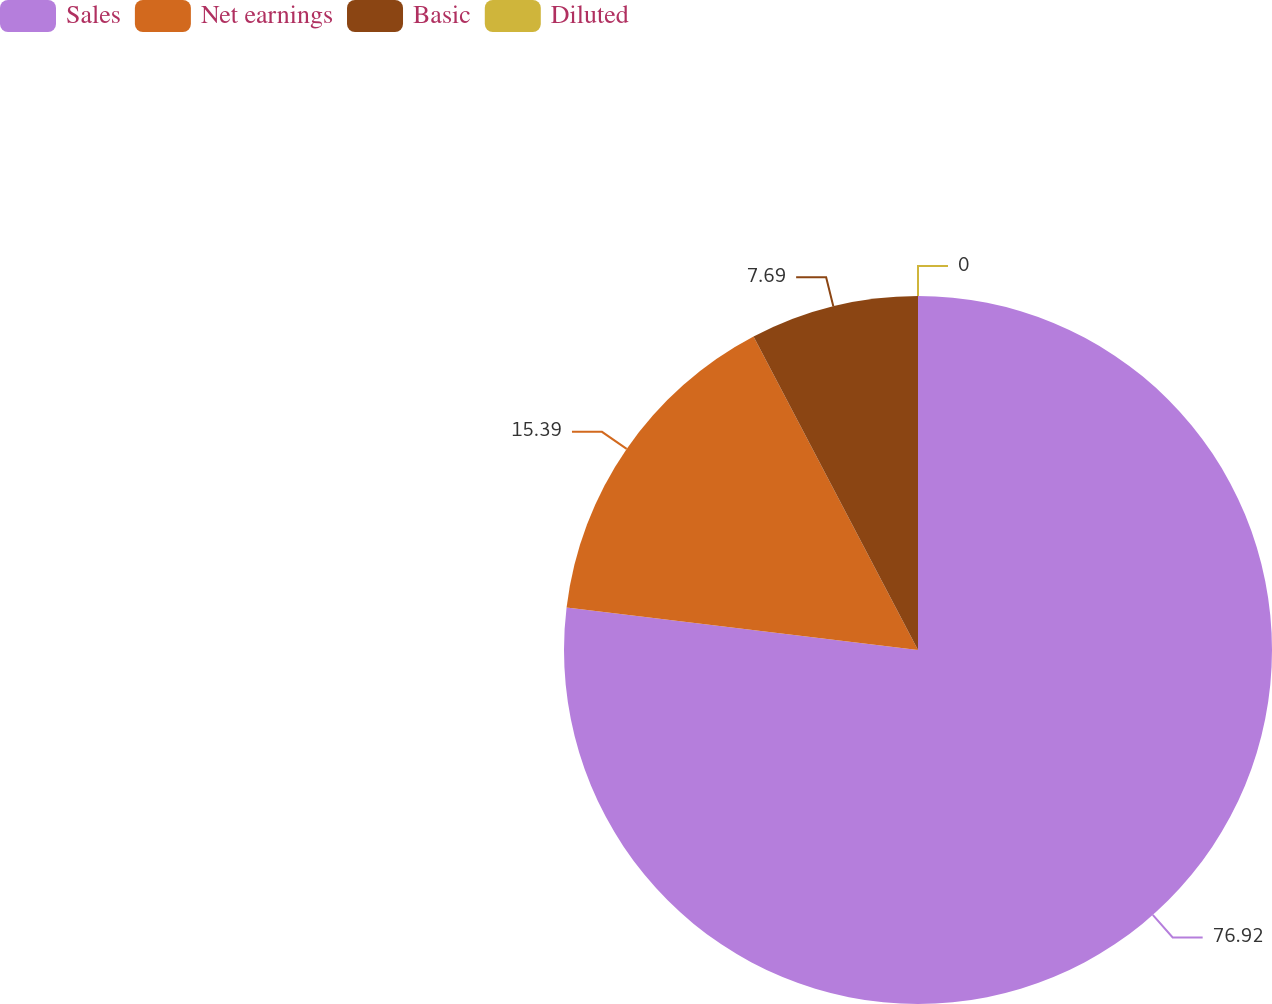<chart> <loc_0><loc_0><loc_500><loc_500><pie_chart><fcel>Sales<fcel>Net earnings<fcel>Basic<fcel>Diluted<nl><fcel>76.92%<fcel>15.39%<fcel>7.69%<fcel>0.0%<nl></chart> 